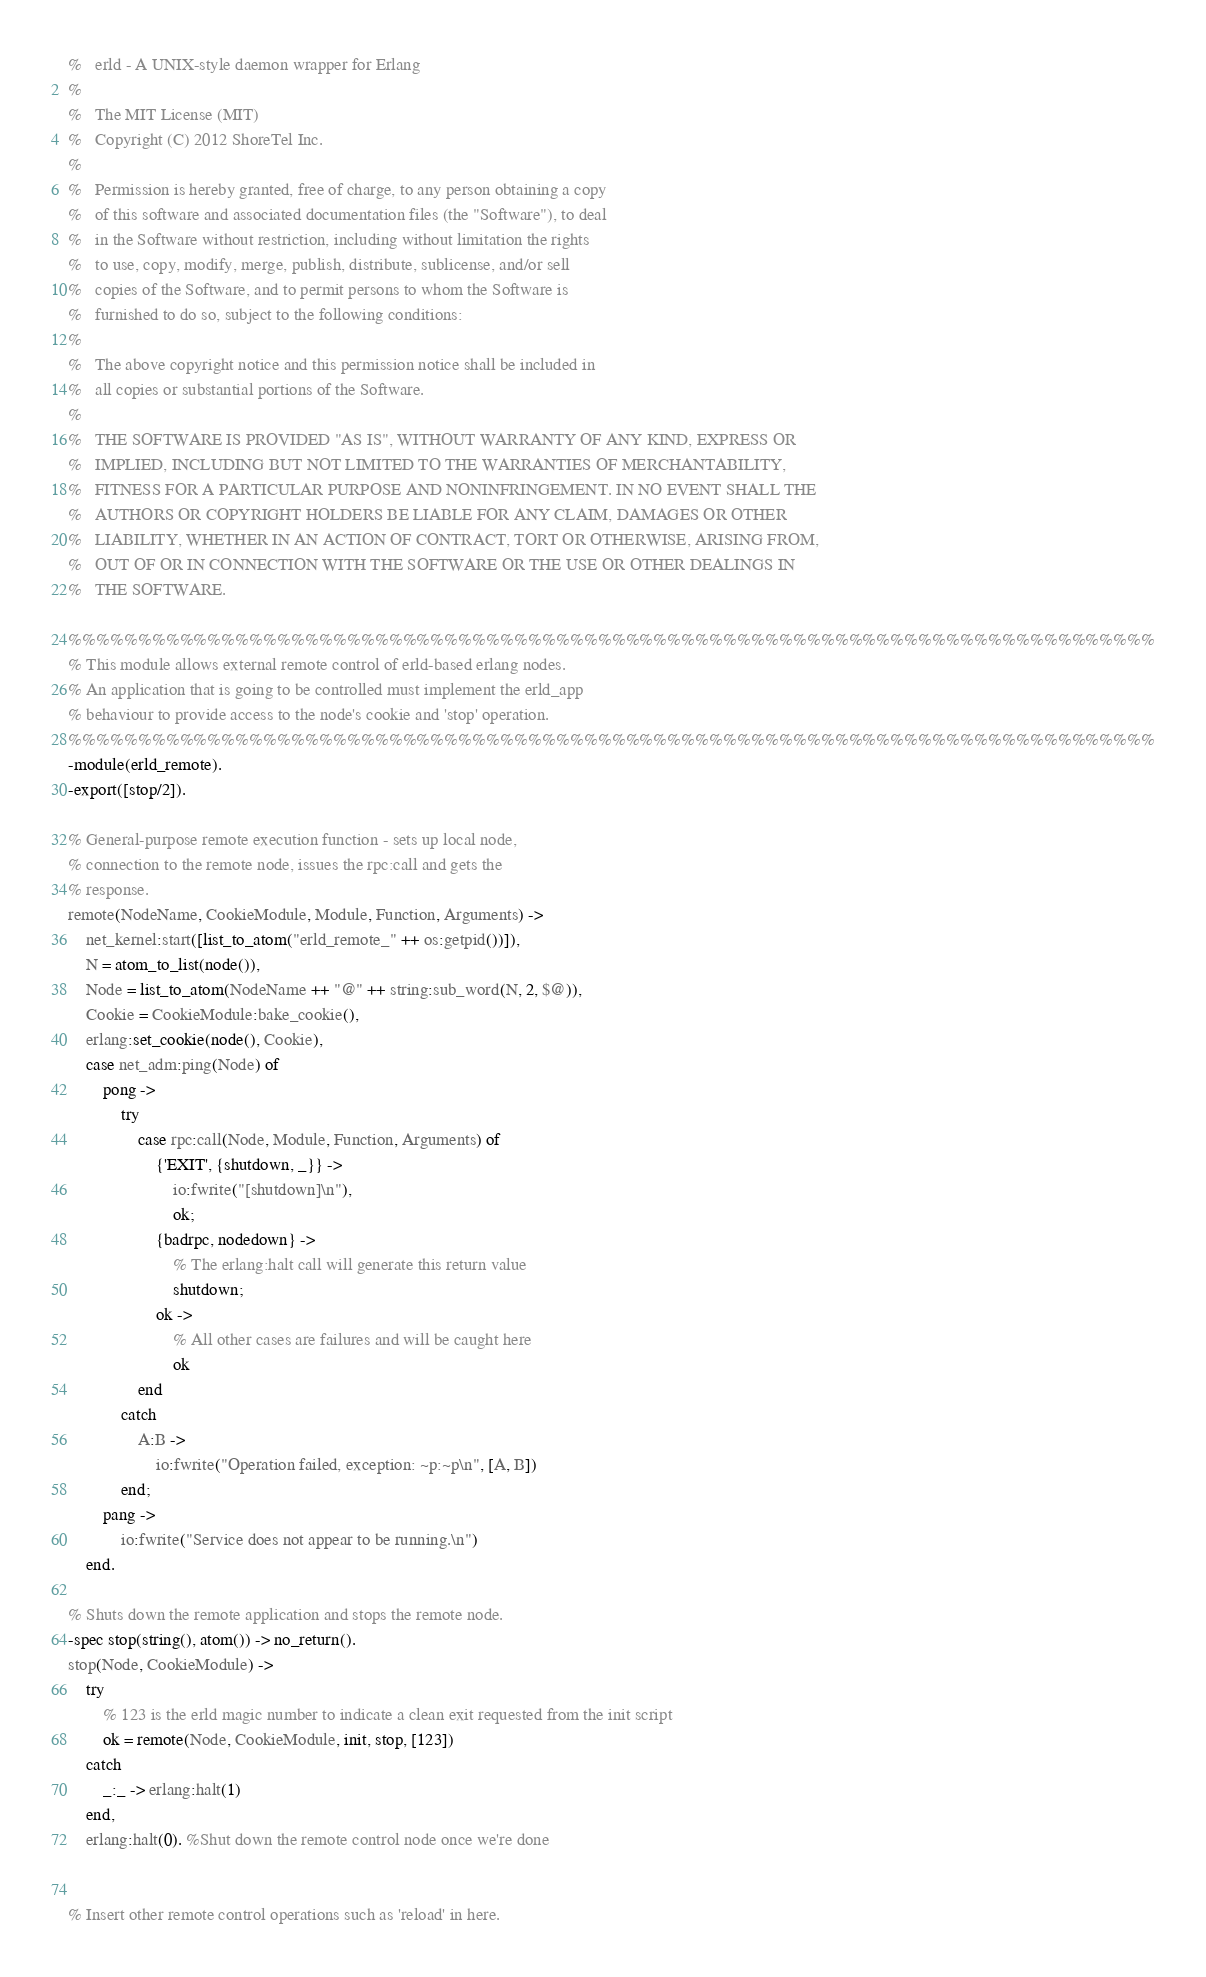Convert code to text. <code><loc_0><loc_0><loc_500><loc_500><_Erlang_>%	erld - A UNIX-style daemon wrapper for Erlang
%
%	The MIT License (MIT)
%	Copyright (C) 2012 ShoreTel Inc.
%
%	Permission is hereby granted, free of charge, to any person obtaining a copy
%	of this software and associated documentation files (the "Software"), to deal
%	in the Software without restriction, including without limitation the rights
%	to use, copy, modify, merge, publish, distribute, sublicense, and/or sell
%	copies of the Software, and to permit persons to whom the Software is
%	furnished to do so, subject to the following conditions:
%
%	The above copyright notice and this permission notice shall be included in
%	all copies or substantial portions of the Software.
%
%	THE SOFTWARE IS PROVIDED "AS IS", WITHOUT WARRANTY OF ANY KIND, EXPRESS OR
%	IMPLIED, INCLUDING BUT NOT LIMITED TO THE WARRANTIES OF MERCHANTABILITY,
%	FITNESS FOR A PARTICULAR PURPOSE AND NONINFRINGEMENT. IN NO EVENT SHALL THE
%	AUTHORS OR COPYRIGHT HOLDERS BE LIABLE FOR ANY CLAIM, DAMAGES OR OTHER
%	LIABILITY, WHETHER IN AN ACTION OF CONTRACT, TORT OR OTHERWISE, ARISING FROM,
%	OUT OF OR IN CONNECTION WITH THE SOFTWARE OR THE USE OR OTHER DEALINGS IN
%	THE SOFTWARE.

%%%%%%%%%%%%%%%%%%%%%%%%%%%%%%%%%%%%%%%%%%%%%%%%%%%%%%%%%%%%%%%%%%%%%%%%%%%%%%
% This module allows external remote control of erld-based erlang nodes.
% An application that is going to be controlled must implement the erld_app
% behaviour to provide access to the node's cookie and 'stop' operation.
%%%%%%%%%%%%%%%%%%%%%%%%%%%%%%%%%%%%%%%%%%%%%%%%%%%%%%%%%%%%%%%%%%%%%%%%%%%%%%
-module(erld_remote).
-export([stop/2]).

% General-purpose remote execution function - sets up local node,
% connection to the remote node, issues the rpc:call and gets the
% response.
remote(NodeName, CookieModule, Module, Function, Arguments) ->
	net_kernel:start([list_to_atom("erld_remote_" ++ os:getpid())]),
	N = atom_to_list(node()),
	Node = list_to_atom(NodeName ++ "@" ++ string:sub_word(N, 2, $@)),
	Cookie = CookieModule:bake_cookie(),
	erlang:set_cookie(node(), Cookie),
	case net_adm:ping(Node) of
		pong ->
			try
				case rpc:call(Node, Module, Function, Arguments) of
					{'EXIT', {shutdown, _}} ->
						io:fwrite("[shutdown]\n"),
						ok;
					{badrpc, nodedown} ->
						% The erlang:halt call will generate this return value
						shutdown;
					ok ->
						% All other cases are failures and will be caught here
						ok
				end
			catch
				A:B ->
					io:fwrite("Operation failed, exception: ~p:~p\n", [A, B])
			end;
		pang ->
			io:fwrite("Service does not appear to be running.\n")
	end.

% Shuts down the remote application and stops the remote node.
-spec stop(string(), atom()) -> no_return().
stop(Node, CookieModule) ->
	try
		% 123 is the erld magic number to indicate a clean exit requested from the init script
		ok = remote(Node, CookieModule, init, stop, [123])
	catch
		_:_ -> erlang:halt(1)
	end,
	erlang:halt(0). %Shut down the remote control node once we're done


% Insert other remote control operations such as 'reload' in here.
</code> 